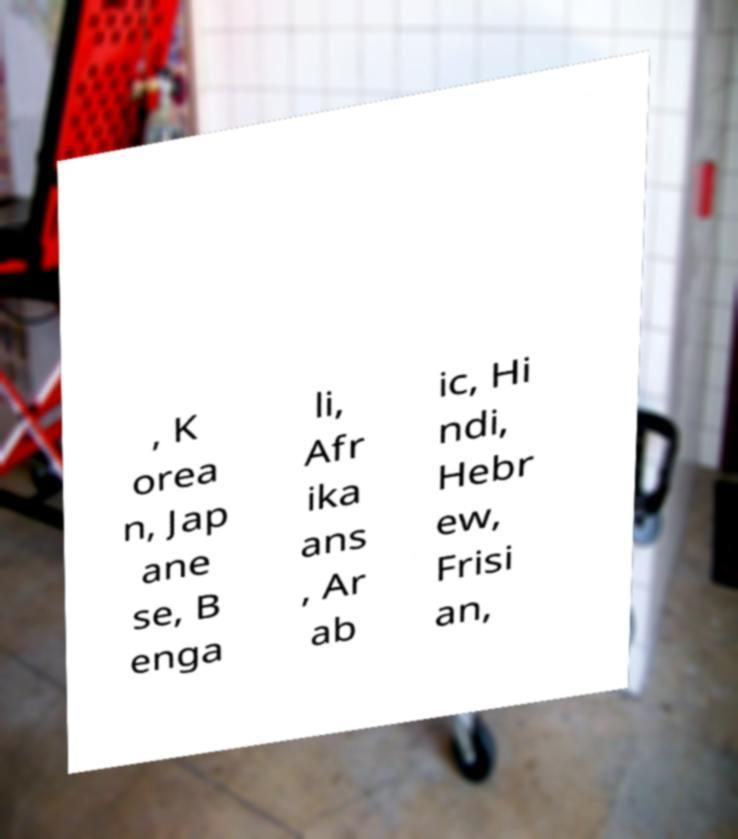Please read and relay the text visible in this image. What does it say? , K orea n, Jap ane se, B enga li, Afr ika ans , Ar ab ic, Hi ndi, Hebr ew, Frisi an, 